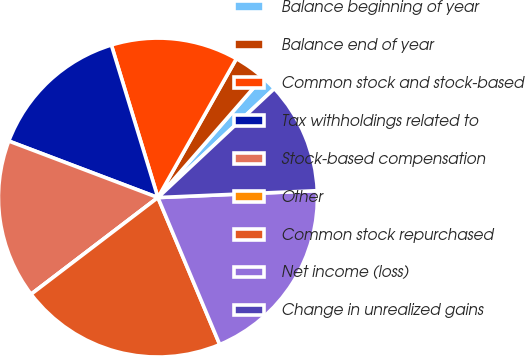Convert chart. <chart><loc_0><loc_0><loc_500><loc_500><pie_chart><fcel>Balance beginning of year<fcel>Balance end of year<fcel>Common stock and stock-based<fcel>Tax withholdings related to<fcel>Stock-based compensation<fcel>Other<fcel>Common stock repurchased<fcel>Net income (loss)<fcel>Change in unrealized gains<nl><fcel>1.61%<fcel>3.23%<fcel>12.9%<fcel>14.52%<fcel>16.13%<fcel>0.0%<fcel>20.97%<fcel>19.35%<fcel>11.29%<nl></chart> 